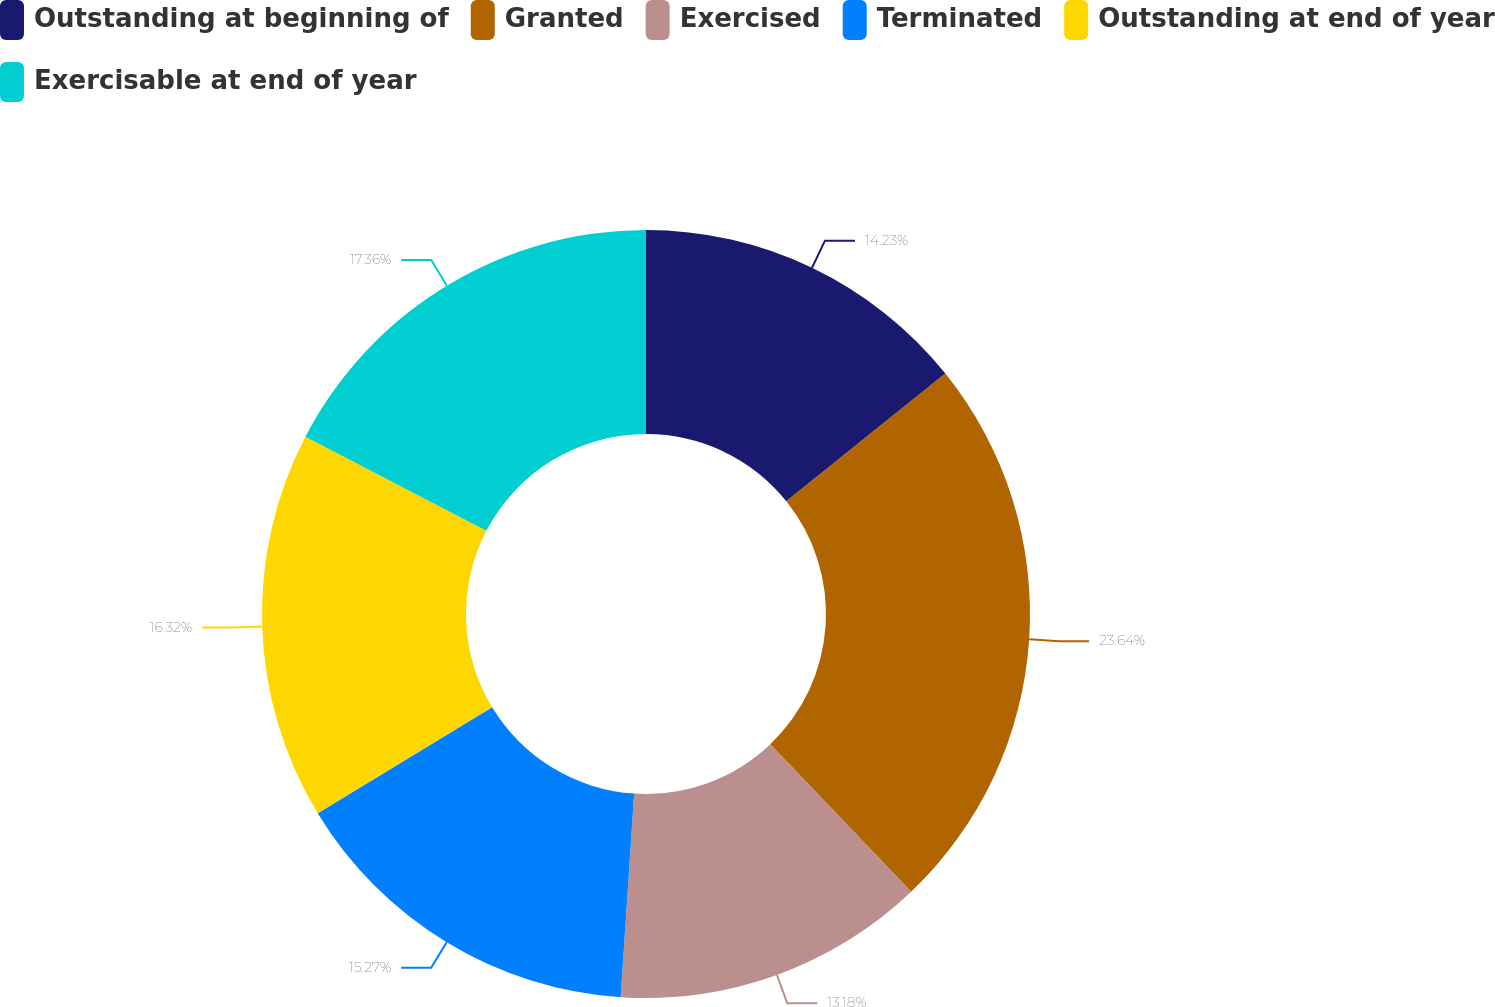<chart> <loc_0><loc_0><loc_500><loc_500><pie_chart><fcel>Outstanding at beginning of<fcel>Granted<fcel>Exercised<fcel>Terminated<fcel>Outstanding at end of year<fcel>Exercisable at end of year<nl><fcel>14.23%<fcel>23.64%<fcel>13.18%<fcel>15.27%<fcel>16.32%<fcel>17.36%<nl></chart> 